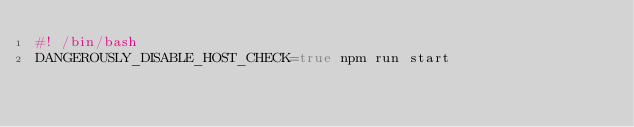Convert code to text. <code><loc_0><loc_0><loc_500><loc_500><_Bash_>#! /bin/bash
DANGEROUSLY_DISABLE_HOST_CHECK=true npm run start</code> 